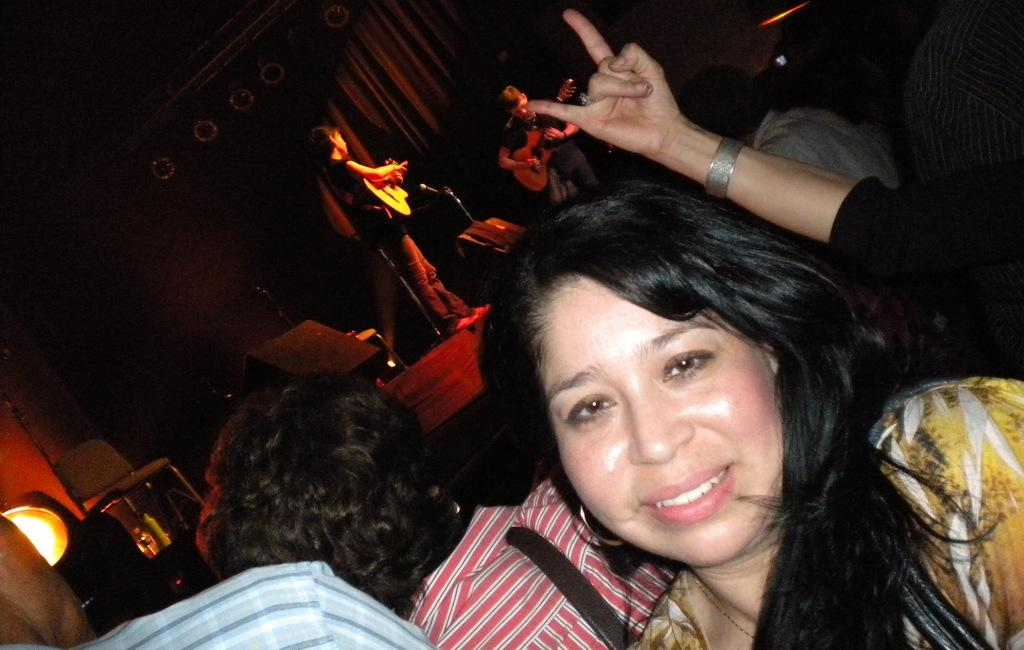What are the people in the image doing? People are playing guitar on the stage in the image. Can you describe the lighting in the image? There is a light on the left side of the image. What else can be seen on the left side of the image? There is a chair on the left side of the image. What type of pies are being served to the audience in the image? There is no mention of pies or any food being served in the image. The focus is on the people playing guitar on the stage. 